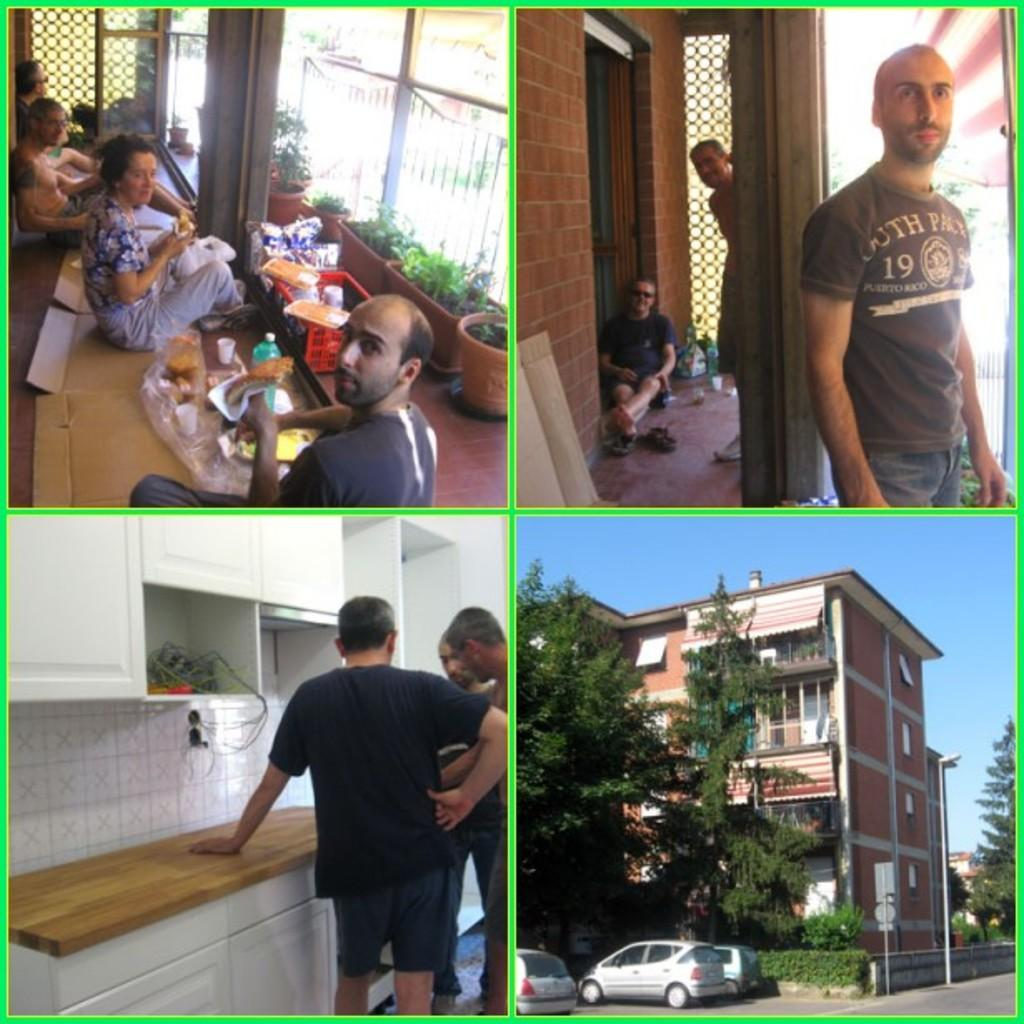What type of artwork is the image? The image is a collage. What types of subjects are included in the collage? There are people, buildings, trees, cars, a table, walls, and house plants in the collage. What part of the natural environment is visible in the collage? The sky is visible in the collage. What type of yam is being discussed by the people in the collage? There is no yam or discussion present in the collage; it features a variety of subjects and objects. What type of account is being managed by the people in the collage? There is no account or financial management activity depicted in the collage. 